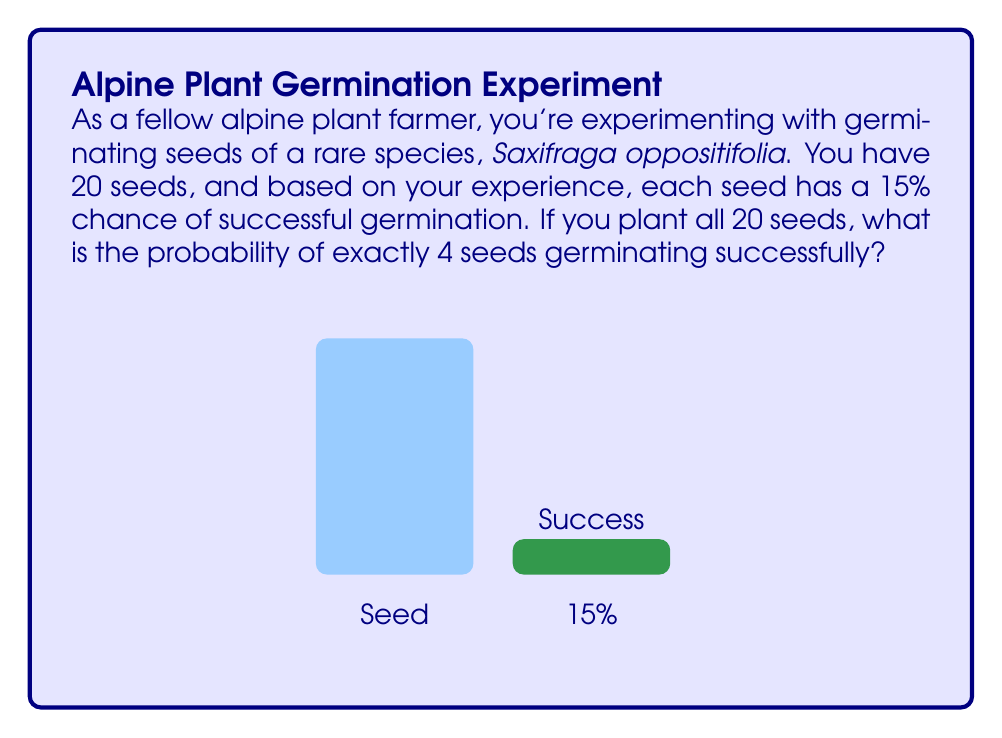Could you help me with this problem? Let's approach this step-by-step using the binomial probability formula:

1) This scenario follows a binomial distribution where:
   - $n = 20$ (total number of seeds)
   - $p = 0.15$ (probability of success for each seed)
   - $k = 4$ (number of successful germinations we're interested in)

2) The binomial probability formula is:

   $P(X = k) = \binom{n}{k} p^k (1-p)^{n-k}$

3) Let's calculate each part:

   $\binom{n}{k} = \binom{20}{4} = \frac{20!}{4!(20-4)!} = 4845$

   $p^k = 0.15^4 \approx 0.0005063$

   $(1-p)^{n-k} = 0.85^{16} \approx 0.0448674$

4) Now, let's put it all together:

   $P(X = 4) = 4845 \times 0.0005063 \times 0.0448674$

5) Calculate the final result:

   $P(X = 4) \approx 0.1101$ or about 11.01%
Answer: $\approx 0.1101$ or 11.01% 